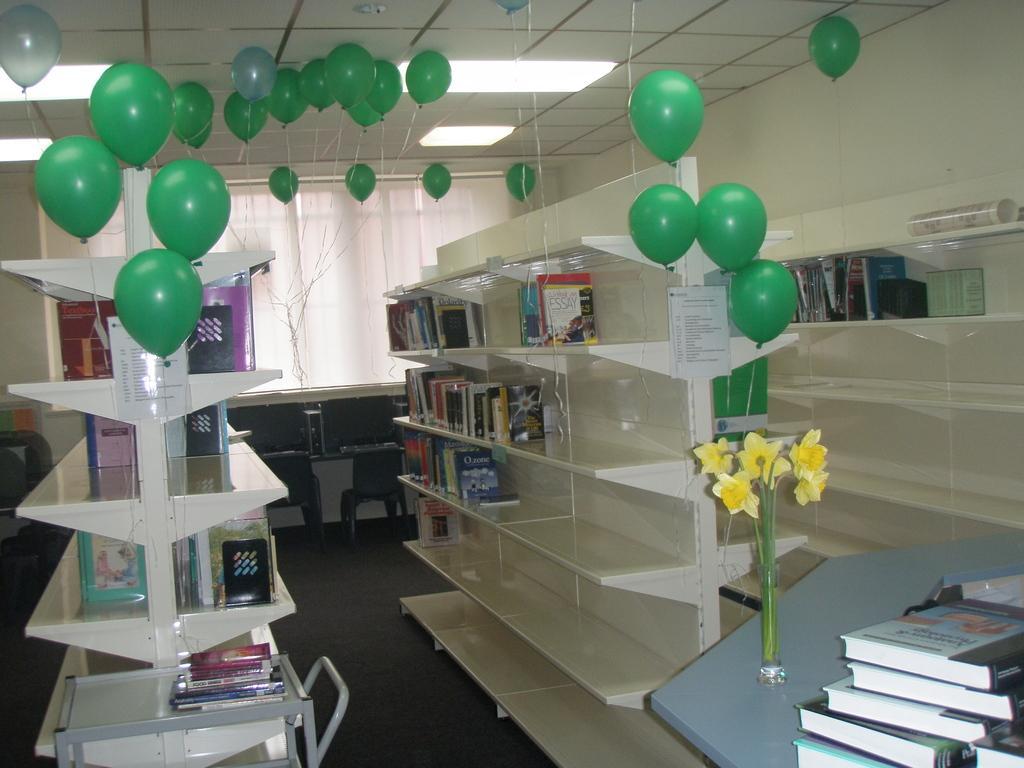Can you describe this image briefly? On the right side there is a table with books. Also there is a vase with flowers on a table. Near to that there are racks. On that there are books. On the left side also there are racks. On the racks there are books. Also there are decorations with balloons. On the ceiling there are lights. In the back there are curtains. 